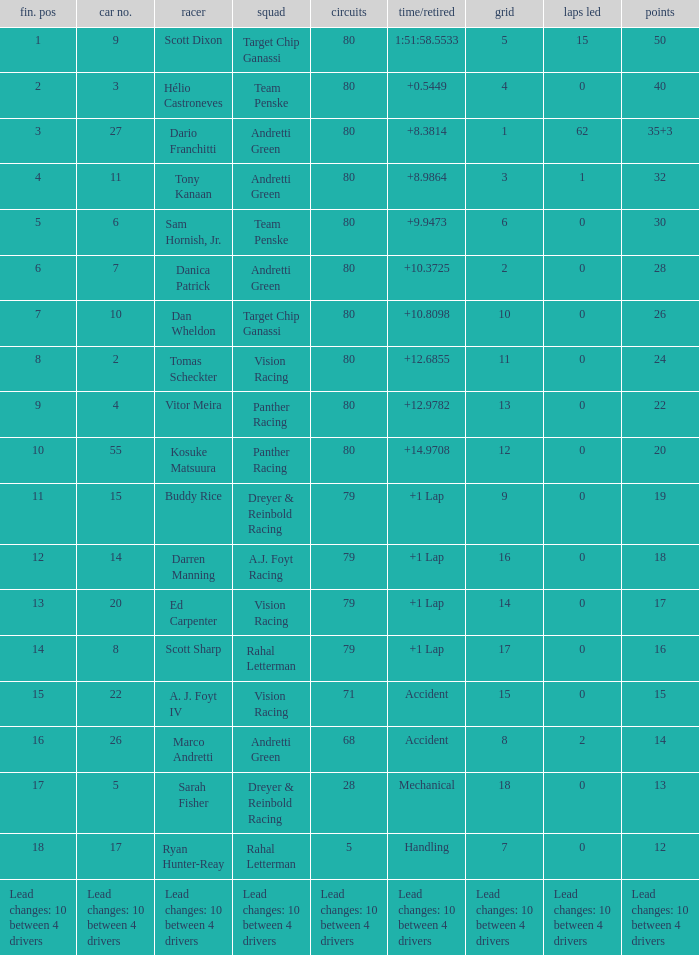What grid has 24 points? 11.0. 